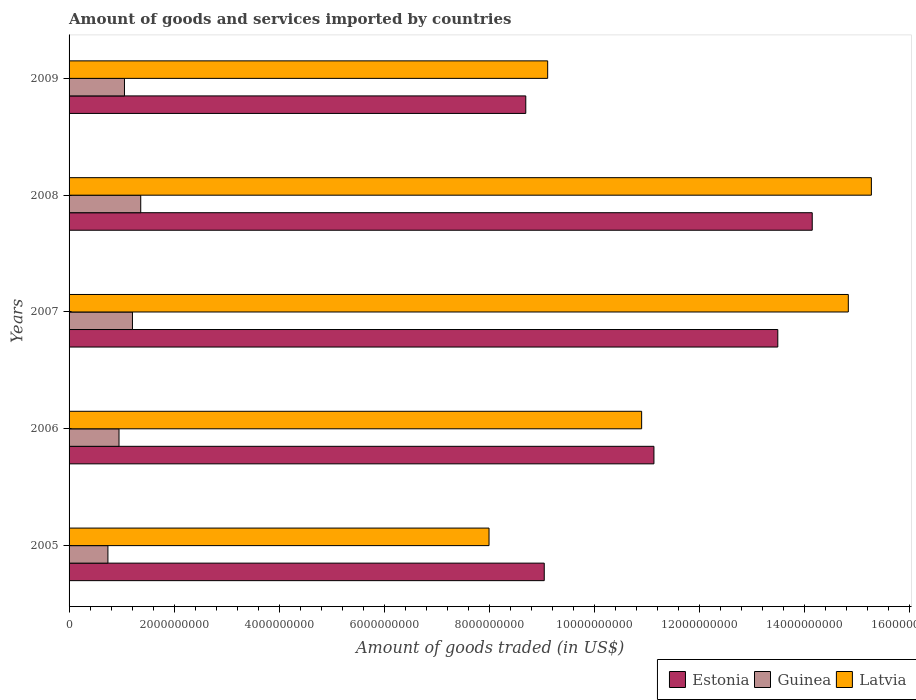How many groups of bars are there?
Your response must be concise. 5. Are the number of bars per tick equal to the number of legend labels?
Your response must be concise. Yes. How many bars are there on the 1st tick from the top?
Offer a terse response. 3. What is the label of the 4th group of bars from the top?
Give a very brief answer. 2006. What is the total amount of goods and services imported in Guinea in 2006?
Make the answer very short. 9.51e+08. Across all years, what is the maximum total amount of goods and services imported in Guinea?
Make the answer very short. 1.36e+09. Across all years, what is the minimum total amount of goods and services imported in Guinea?
Your answer should be compact. 7.40e+08. In which year was the total amount of goods and services imported in Estonia minimum?
Provide a short and direct response. 2009. What is the total total amount of goods and services imported in Latvia in the graph?
Your answer should be compact. 5.81e+1. What is the difference between the total amount of goods and services imported in Estonia in 2007 and that in 2008?
Your response must be concise. -6.55e+08. What is the difference between the total amount of goods and services imported in Estonia in 2009 and the total amount of goods and services imported in Guinea in 2008?
Provide a short and direct response. 7.33e+09. What is the average total amount of goods and services imported in Guinea per year?
Give a very brief answer. 1.06e+09. In the year 2008, what is the difference between the total amount of goods and services imported in Guinea and total amount of goods and services imported in Estonia?
Make the answer very short. -1.28e+1. What is the ratio of the total amount of goods and services imported in Estonia in 2006 to that in 2007?
Offer a terse response. 0.83. Is the total amount of goods and services imported in Estonia in 2005 less than that in 2009?
Your answer should be compact. No. What is the difference between the highest and the second highest total amount of goods and services imported in Latvia?
Ensure brevity in your answer.  4.39e+08. What is the difference between the highest and the lowest total amount of goods and services imported in Estonia?
Your answer should be compact. 5.45e+09. In how many years, is the total amount of goods and services imported in Latvia greater than the average total amount of goods and services imported in Latvia taken over all years?
Offer a very short reply. 2. Is the sum of the total amount of goods and services imported in Guinea in 2005 and 2008 greater than the maximum total amount of goods and services imported in Latvia across all years?
Your answer should be very brief. No. What does the 1st bar from the top in 2006 represents?
Provide a short and direct response. Latvia. What does the 3rd bar from the bottom in 2005 represents?
Provide a succinct answer. Latvia. Are all the bars in the graph horizontal?
Give a very brief answer. Yes. What is the difference between two consecutive major ticks on the X-axis?
Offer a very short reply. 2.00e+09. Are the values on the major ticks of X-axis written in scientific E-notation?
Ensure brevity in your answer.  No. Does the graph contain any zero values?
Keep it short and to the point. No. Does the graph contain grids?
Your answer should be compact. No. Where does the legend appear in the graph?
Your answer should be compact. Bottom right. How many legend labels are there?
Give a very brief answer. 3. How are the legend labels stacked?
Your answer should be compact. Horizontal. What is the title of the graph?
Give a very brief answer. Amount of goods and services imported by countries. What is the label or title of the X-axis?
Provide a short and direct response. Amount of goods traded (in US$). What is the label or title of the Y-axis?
Your answer should be very brief. Years. What is the Amount of goods traded (in US$) of Estonia in 2005?
Make the answer very short. 9.05e+09. What is the Amount of goods traded (in US$) of Guinea in 2005?
Your answer should be very brief. 7.40e+08. What is the Amount of goods traded (in US$) of Latvia in 2005?
Keep it short and to the point. 7.99e+09. What is the Amount of goods traded (in US$) in Estonia in 2006?
Provide a short and direct response. 1.11e+1. What is the Amount of goods traded (in US$) in Guinea in 2006?
Offer a terse response. 9.51e+08. What is the Amount of goods traded (in US$) in Latvia in 2006?
Offer a very short reply. 1.09e+1. What is the Amount of goods traded (in US$) of Estonia in 2007?
Offer a terse response. 1.35e+1. What is the Amount of goods traded (in US$) of Guinea in 2007?
Make the answer very short. 1.21e+09. What is the Amount of goods traded (in US$) in Latvia in 2007?
Ensure brevity in your answer.  1.48e+1. What is the Amount of goods traded (in US$) in Estonia in 2008?
Give a very brief answer. 1.41e+1. What is the Amount of goods traded (in US$) of Guinea in 2008?
Give a very brief answer. 1.36e+09. What is the Amount of goods traded (in US$) of Latvia in 2008?
Give a very brief answer. 1.53e+1. What is the Amount of goods traded (in US$) of Estonia in 2009?
Make the answer very short. 8.69e+09. What is the Amount of goods traded (in US$) of Guinea in 2009?
Your answer should be very brief. 1.05e+09. What is the Amount of goods traded (in US$) of Latvia in 2009?
Your answer should be very brief. 9.11e+09. Across all years, what is the maximum Amount of goods traded (in US$) in Estonia?
Your response must be concise. 1.41e+1. Across all years, what is the maximum Amount of goods traded (in US$) in Guinea?
Give a very brief answer. 1.36e+09. Across all years, what is the maximum Amount of goods traded (in US$) in Latvia?
Provide a succinct answer. 1.53e+1. Across all years, what is the minimum Amount of goods traded (in US$) of Estonia?
Offer a terse response. 8.69e+09. Across all years, what is the minimum Amount of goods traded (in US$) in Guinea?
Your answer should be very brief. 7.40e+08. Across all years, what is the minimum Amount of goods traded (in US$) of Latvia?
Give a very brief answer. 7.99e+09. What is the total Amount of goods traded (in US$) of Estonia in the graph?
Offer a terse response. 5.65e+1. What is the total Amount of goods traded (in US$) of Guinea in the graph?
Make the answer very short. 5.32e+09. What is the total Amount of goods traded (in US$) of Latvia in the graph?
Offer a terse response. 5.81e+1. What is the difference between the Amount of goods traded (in US$) in Estonia in 2005 and that in 2006?
Your response must be concise. -2.09e+09. What is the difference between the Amount of goods traded (in US$) in Guinea in 2005 and that in 2006?
Offer a very short reply. -2.11e+08. What is the difference between the Amount of goods traded (in US$) of Latvia in 2005 and that in 2006?
Your answer should be very brief. -2.90e+09. What is the difference between the Amount of goods traded (in US$) in Estonia in 2005 and that in 2007?
Ensure brevity in your answer.  -4.45e+09. What is the difference between the Amount of goods traded (in US$) in Guinea in 2005 and that in 2007?
Make the answer very short. -4.67e+08. What is the difference between the Amount of goods traded (in US$) of Latvia in 2005 and that in 2007?
Keep it short and to the point. -6.84e+09. What is the difference between the Amount of goods traded (in US$) of Estonia in 2005 and that in 2008?
Make the answer very short. -5.10e+09. What is the difference between the Amount of goods traded (in US$) of Guinea in 2005 and that in 2008?
Provide a succinct answer. -6.25e+08. What is the difference between the Amount of goods traded (in US$) of Latvia in 2005 and that in 2008?
Your answer should be very brief. -7.28e+09. What is the difference between the Amount of goods traded (in US$) of Estonia in 2005 and that in 2009?
Your response must be concise. 3.52e+08. What is the difference between the Amount of goods traded (in US$) in Guinea in 2005 and that in 2009?
Ensure brevity in your answer.  -3.15e+08. What is the difference between the Amount of goods traded (in US$) of Latvia in 2005 and that in 2009?
Ensure brevity in your answer.  -1.12e+09. What is the difference between the Amount of goods traded (in US$) in Estonia in 2006 and that in 2007?
Your answer should be compact. -2.36e+09. What is the difference between the Amount of goods traded (in US$) in Guinea in 2006 and that in 2007?
Your answer should be very brief. -2.56e+08. What is the difference between the Amount of goods traded (in US$) of Latvia in 2006 and that in 2007?
Ensure brevity in your answer.  -3.93e+09. What is the difference between the Amount of goods traded (in US$) in Estonia in 2006 and that in 2008?
Your answer should be very brief. -3.01e+09. What is the difference between the Amount of goods traded (in US$) of Guinea in 2006 and that in 2008?
Your response must be concise. -4.14e+08. What is the difference between the Amount of goods traded (in US$) of Latvia in 2006 and that in 2008?
Your response must be concise. -4.37e+09. What is the difference between the Amount of goods traded (in US$) in Estonia in 2006 and that in 2009?
Ensure brevity in your answer.  2.44e+09. What is the difference between the Amount of goods traded (in US$) of Guinea in 2006 and that in 2009?
Give a very brief answer. -1.04e+08. What is the difference between the Amount of goods traded (in US$) in Latvia in 2006 and that in 2009?
Provide a succinct answer. 1.79e+09. What is the difference between the Amount of goods traded (in US$) of Estonia in 2007 and that in 2008?
Your answer should be compact. -6.55e+08. What is the difference between the Amount of goods traded (in US$) in Guinea in 2007 and that in 2008?
Offer a very short reply. -1.58e+08. What is the difference between the Amount of goods traded (in US$) in Latvia in 2007 and that in 2008?
Your answer should be compact. -4.39e+08. What is the difference between the Amount of goods traded (in US$) in Estonia in 2007 and that in 2009?
Ensure brevity in your answer.  4.80e+09. What is the difference between the Amount of goods traded (in US$) of Guinea in 2007 and that in 2009?
Your response must be concise. 1.52e+08. What is the difference between the Amount of goods traded (in US$) in Latvia in 2007 and that in 2009?
Provide a succinct answer. 5.72e+09. What is the difference between the Amount of goods traded (in US$) of Estonia in 2008 and that in 2009?
Your answer should be compact. 5.45e+09. What is the difference between the Amount of goods traded (in US$) in Guinea in 2008 and that in 2009?
Provide a succinct answer. 3.10e+08. What is the difference between the Amount of goods traded (in US$) of Latvia in 2008 and that in 2009?
Provide a short and direct response. 6.16e+09. What is the difference between the Amount of goods traded (in US$) in Estonia in 2005 and the Amount of goods traded (in US$) in Guinea in 2006?
Ensure brevity in your answer.  8.10e+09. What is the difference between the Amount of goods traded (in US$) in Estonia in 2005 and the Amount of goods traded (in US$) in Latvia in 2006?
Ensure brevity in your answer.  -1.85e+09. What is the difference between the Amount of goods traded (in US$) in Guinea in 2005 and the Amount of goods traded (in US$) in Latvia in 2006?
Provide a succinct answer. -1.02e+1. What is the difference between the Amount of goods traded (in US$) of Estonia in 2005 and the Amount of goods traded (in US$) of Guinea in 2007?
Offer a very short reply. 7.84e+09. What is the difference between the Amount of goods traded (in US$) in Estonia in 2005 and the Amount of goods traded (in US$) in Latvia in 2007?
Your answer should be compact. -5.79e+09. What is the difference between the Amount of goods traded (in US$) in Guinea in 2005 and the Amount of goods traded (in US$) in Latvia in 2007?
Offer a very short reply. -1.41e+1. What is the difference between the Amount of goods traded (in US$) in Estonia in 2005 and the Amount of goods traded (in US$) in Guinea in 2008?
Give a very brief answer. 7.68e+09. What is the difference between the Amount of goods traded (in US$) in Estonia in 2005 and the Amount of goods traded (in US$) in Latvia in 2008?
Offer a terse response. -6.23e+09. What is the difference between the Amount of goods traded (in US$) of Guinea in 2005 and the Amount of goods traded (in US$) of Latvia in 2008?
Your answer should be very brief. -1.45e+1. What is the difference between the Amount of goods traded (in US$) in Estonia in 2005 and the Amount of goods traded (in US$) in Guinea in 2009?
Keep it short and to the point. 7.99e+09. What is the difference between the Amount of goods traded (in US$) of Estonia in 2005 and the Amount of goods traded (in US$) of Latvia in 2009?
Your answer should be very brief. -6.51e+07. What is the difference between the Amount of goods traded (in US$) in Guinea in 2005 and the Amount of goods traded (in US$) in Latvia in 2009?
Ensure brevity in your answer.  -8.37e+09. What is the difference between the Amount of goods traded (in US$) in Estonia in 2006 and the Amount of goods traded (in US$) in Guinea in 2007?
Offer a very short reply. 9.93e+09. What is the difference between the Amount of goods traded (in US$) of Estonia in 2006 and the Amount of goods traded (in US$) of Latvia in 2007?
Your response must be concise. -3.70e+09. What is the difference between the Amount of goods traded (in US$) of Guinea in 2006 and the Amount of goods traded (in US$) of Latvia in 2007?
Your answer should be very brief. -1.39e+1. What is the difference between the Amount of goods traded (in US$) in Estonia in 2006 and the Amount of goods traded (in US$) in Guinea in 2008?
Your answer should be very brief. 9.77e+09. What is the difference between the Amount of goods traded (in US$) of Estonia in 2006 and the Amount of goods traded (in US$) of Latvia in 2008?
Provide a succinct answer. -4.14e+09. What is the difference between the Amount of goods traded (in US$) in Guinea in 2006 and the Amount of goods traded (in US$) in Latvia in 2008?
Make the answer very short. -1.43e+1. What is the difference between the Amount of goods traded (in US$) in Estonia in 2006 and the Amount of goods traded (in US$) in Guinea in 2009?
Your answer should be very brief. 1.01e+1. What is the difference between the Amount of goods traded (in US$) in Estonia in 2006 and the Amount of goods traded (in US$) in Latvia in 2009?
Your response must be concise. 2.02e+09. What is the difference between the Amount of goods traded (in US$) in Guinea in 2006 and the Amount of goods traded (in US$) in Latvia in 2009?
Offer a very short reply. -8.16e+09. What is the difference between the Amount of goods traded (in US$) of Estonia in 2007 and the Amount of goods traded (in US$) of Guinea in 2008?
Ensure brevity in your answer.  1.21e+1. What is the difference between the Amount of goods traded (in US$) of Estonia in 2007 and the Amount of goods traded (in US$) of Latvia in 2008?
Make the answer very short. -1.78e+09. What is the difference between the Amount of goods traded (in US$) in Guinea in 2007 and the Amount of goods traded (in US$) in Latvia in 2008?
Provide a short and direct response. -1.41e+1. What is the difference between the Amount of goods traded (in US$) of Estonia in 2007 and the Amount of goods traded (in US$) of Guinea in 2009?
Make the answer very short. 1.24e+1. What is the difference between the Amount of goods traded (in US$) of Estonia in 2007 and the Amount of goods traded (in US$) of Latvia in 2009?
Your answer should be very brief. 4.38e+09. What is the difference between the Amount of goods traded (in US$) of Guinea in 2007 and the Amount of goods traded (in US$) of Latvia in 2009?
Provide a succinct answer. -7.90e+09. What is the difference between the Amount of goods traded (in US$) in Estonia in 2008 and the Amount of goods traded (in US$) in Guinea in 2009?
Provide a short and direct response. 1.31e+1. What is the difference between the Amount of goods traded (in US$) of Estonia in 2008 and the Amount of goods traded (in US$) of Latvia in 2009?
Make the answer very short. 5.04e+09. What is the difference between the Amount of goods traded (in US$) of Guinea in 2008 and the Amount of goods traded (in US$) of Latvia in 2009?
Your answer should be compact. -7.75e+09. What is the average Amount of goods traded (in US$) of Estonia per year?
Offer a terse response. 1.13e+1. What is the average Amount of goods traded (in US$) of Guinea per year?
Make the answer very short. 1.06e+09. What is the average Amount of goods traded (in US$) in Latvia per year?
Provide a succinct answer. 1.16e+1. In the year 2005, what is the difference between the Amount of goods traded (in US$) in Estonia and Amount of goods traded (in US$) in Guinea?
Provide a succinct answer. 8.31e+09. In the year 2005, what is the difference between the Amount of goods traded (in US$) in Estonia and Amount of goods traded (in US$) in Latvia?
Give a very brief answer. 1.05e+09. In the year 2005, what is the difference between the Amount of goods traded (in US$) in Guinea and Amount of goods traded (in US$) in Latvia?
Keep it short and to the point. -7.26e+09. In the year 2006, what is the difference between the Amount of goods traded (in US$) of Estonia and Amount of goods traded (in US$) of Guinea?
Make the answer very short. 1.02e+1. In the year 2006, what is the difference between the Amount of goods traded (in US$) in Estonia and Amount of goods traded (in US$) in Latvia?
Offer a very short reply. 2.34e+08. In the year 2006, what is the difference between the Amount of goods traded (in US$) in Guinea and Amount of goods traded (in US$) in Latvia?
Ensure brevity in your answer.  -9.95e+09. In the year 2007, what is the difference between the Amount of goods traded (in US$) of Estonia and Amount of goods traded (in US$) of Guinea?
Offer a very short reply. 1.23e+1. In the year 2007, what is the difference between the Amount of goods traded (in US$) in Estonia and Amount of goods traded (in US$) in Latvia?
Your answer should be very brief. -1.34e+09. In the year 2007, what is the difference between the Amount of goods traded (in US$) of Guinea and Amount of goods traded (in US$) of Latvia?
Give a very brief answer. -1.36e+1. In the year 2008, what is the difference between the Amount of goods traded (in US$) of Estonia and Amount of goods traded (in US$) of Guinea?
Give a very brief answer. 1.28e+1. In the year 2008, what is the difference between the Amount of goods traded (in US$) of Estonia and Amount of goods traded (in US$) of Latvia?
Your response must be concise. -1.13e+09. In the year 2008, what is the difference between the Amount of goods traded (in US$) of Guinea and Amount of goods traded (in US$) of Latvia?
Offer a very short reply. -1.39e+1. In the year 2009, what is the difference between the Amount of goods traded (in US$) of Estonia and Amount of goods traded (in US$) of Guinea?
Offer a terse response. 7.64e+09. In the year 2009, what is the difference between the Amount of goods traded (in US$) of Estonia and Amount of goods traded (in US$) of Latvia?
Your answer should be compact. -4.17e+08. In the year 2009, what is the difference between the Amount of goods traded (in US$) of Guinea and Amount of goods traded (in US$) of Latvia?
Offer a very short reply. -8.06e+09. What is the ratio of the Amount of goods traded (in US$) of Estonia in 2005 to that in 2006?
Make the answer very short. 0.81. What is the ratio of the Amount of goods traded (in US$) of Guinea in 2005 to that in 2006?
Make the answer very short. 0.78. What is the ratio of the Amount of goods traded (in US$) of Latvia in 2005 to that in 2006?
Offer a terse response. 0.73. What is the ratio of the Amount of goods traded (in US$) in Estonia in 2005 to that in 2007?
Provide a short and direct response. 0.67. What is the ratio of the Amount of goods traded (in US$) in Guinea in 2005 to that in 2007?
Give a very brief answer. 0.61. What is the ratio of the Amount of goods traded (in US$) in Latvia in 2005 to that in 2007?
Provide a short and direct response. 0.54. What is the ratio of the Amount of goods traded (in US$) in Estonia in 2005 to that in 2008?
Make the answer very short. 0.64. What is the ratio of the Amount of goods traded (in US$) in Guinea in 2005 to that in 2008?
Your answer should be very brief. 0.54. What is the ratio of the Amount of goods traded (in US$) in Latvia in 2005 to that in 2008?
Provide a succinct answer. 0.52. What is the ratio of the Amount of goods traded (in US$) in Estonia in 2005 to that in 2009?
Give a very brief answer. 1.04. What is the ratio of the Amount of goods traded (in US$) of Guinea in 2005 to that in 2009?
Ensure brevity in your answer.  0.7. What is the ratio of the Amount of goods traded (in US$) in Latvia in 2005 to that in 2009?
Your response must be concise. 0.88. What is the ratio of the Amount of goods traded (in US$) of Estonia in 2006 to that in 2007?
Keep it short and to the point. 0.83. What is the ratio of the Amount of goods traded (in US$) of Guinea in 2006 to that in 2007?
Ensure brevity in your answer.  0.79. What is the ratio of the Amount of goods traded (in US$) in Latvia in 2006 to that in 2007?
Keep it short and to the point. 0.73. What is the ratio of the Amount of goods traded (in US$) in Estonia in 2006 to that in 2008?
Offer a very short reply. 0.79. What is the ratio of the Amount of goods traded (in US$) of Guinea in 2006 to that in 2008?
Offer a very short reply. 0.7. What is the ratio of the Amount of goods traded (in US$) in Latvia in 2006 to that in 2008?
Make the answer very short. 0.71. What is the ratio of the Amount of goods traded (in US$) of Estonia in 2006 to that in 2009?
Give a very brief answer. 1.28. What is the ratio of the Amount of goods traded (in US$) of Guinea in 2006 to that in 2009?
Provide a short and direct response. 0.9. What is the ratio of the Amount of goods traded (in US$) of Latvia in 2006 to that in 2009?
Make the answer very short. 1.2. What is the ratio of the Amount of goods traded (in US$) of Estonia in 2007 to that in 2008?
Offer a terse response. 0.95. What is the ratio of the Amount of goods traded (in US$) of Guinea in 2007 to that in 2008?
Keep it short and to the point. 0.88. What is the ratio of the Amount of goods traded (in US$) in Latvia in 2007 to that in 2008?
Ensure brevity in your answer.  0.97. What is the ratio of the Amount of goods traded (in US$) in Estonia in 2007 to that in 2009?
Provide a short and direct response. 1.55. What is the ratio of the Amount of goods traded (in US$) of Guinea in 2007 to that in 2009?
Your answer should be compact. 1.14. What is the ratio of the Amount of goods traded (in US$) of Latvia in 2007 to that in 2009?
Your response must be concise. 1.63. What is the ratio of the Amount of goods traded (in US$) of Estonia in 2008 to that in 2009?
Your response must be concise. 1.63. What is the ratio of the Amount of goods traded (in US$) of Guinea in 2008 to that in 2009?
Give a very brief answer. 1.29. What is the ratio of the Amount of goods traded (in US$) of Latvia in 2008 to that in 2009?
Make the answer very short. 1.68. What is the difference between the highest and the second highest Amount of goods traded (in US$) in Estonia?
Ensure brevity in your answer.  6.55e+08. What is the difference between the highest and the second highest Amount of goods traded (in US$) in Guinea?
Ensure brevity in your answer.  1.58e+08. What is the difference between the highest and the second highest Amount of goods traded (in US$) in Latvia?
Your answer should be compact. 4.39e+08. What is the difference between the highest and the lowest Amount of goods traded (in US$) in Estonia?
Give a very brief answer. 5.45e+09. What is the difference between the highest and the lowest Amount of goods traded (in US$) in Guinea?
Provide a short and direct response. 6.25e+08. What is the difference between the highest and the lowest Amount of goods traded (in US$) of Latvia?
Provide a succinct answer. 7.28e+09. 